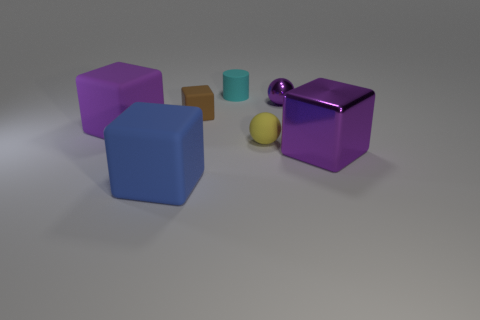Is there any other thing that has the same size as the blue rubber thing?
Offer a very short reply. Yes. What is the size of the shiny thing to the left of the purple object that is to the right of the purple ball?
Keep it short and to the point. Small. Are there the same number of cyan rubber cylinders that are on the right side of the purple shiny cube and blue matte cubes that are right of the blue thing?
Your answer should be very brief. Yes. There is a big cube right of the tiny cube; are there any blue objects that are to the right of it?
Offer a very short reply. No. What number of tiny purple shiny things are to the left of the tiny metal object that is behind the big purple object that is to the right of the tiny purple sphere?
Make the answer very short. 0. Is the number of purple objects less than the number of large purple balls?
Make the answer very short. No. There is a big matte object in front of the yellow matte object; does it have the same shape as the large purple object on the left side of the small cyan matte cylinder?
Provide a short and direct response. Yes. What color is the cylinder?
Offer a terse response. Cyan. What number of matte objects are brown things or tiny purple objects?
Offer a very short reply. 1. The other metal object that is the same shape as the tiny brown object is what color?
Give a very brief answer. Purple. 